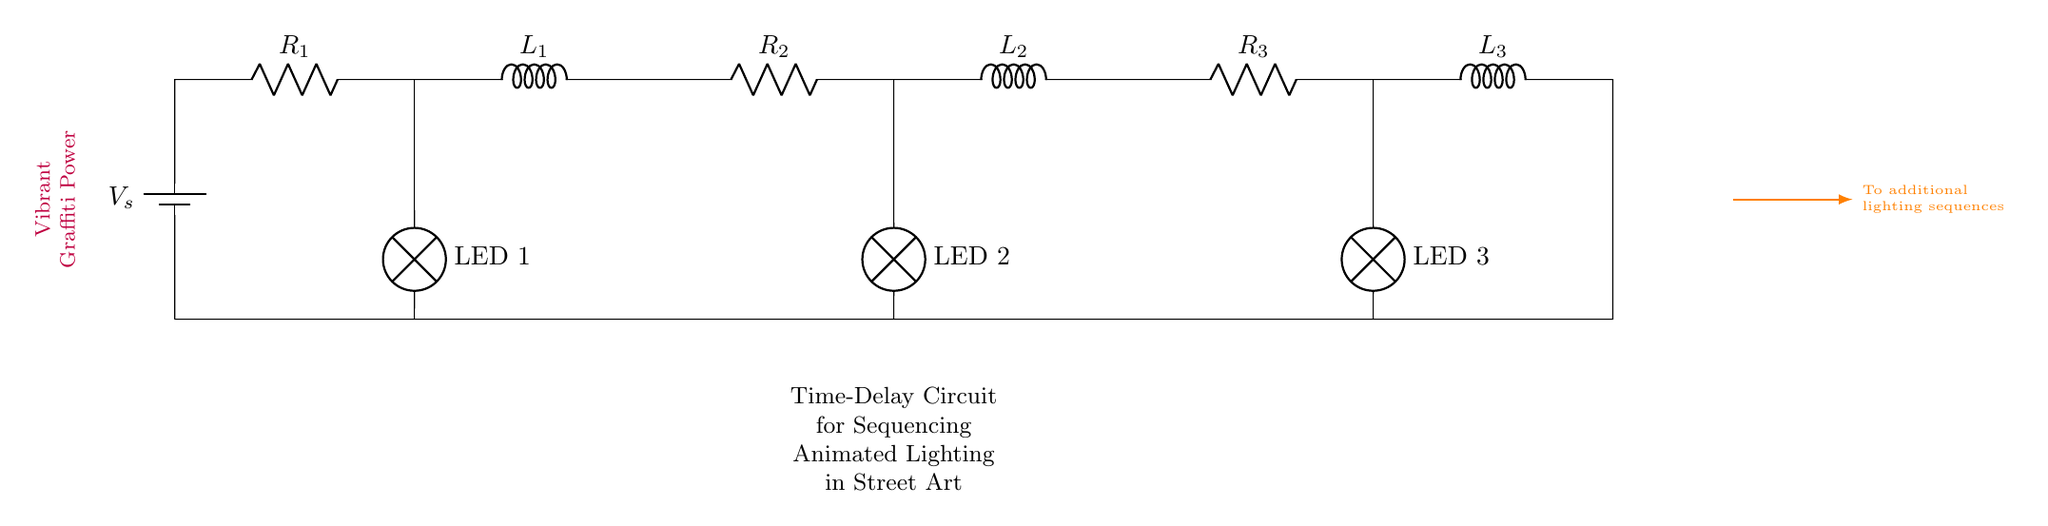What is the number of resistors in the circuit? There are three resistors shown in the circuit diagram, indicated by the symbols labeled R1, R2, and R3.
Answer: three What is the function of the inductors in this circuit? The inductors (L1, L2, and L3) are used for energy storage and to create time delays in the circuit, affecting the timing of the LED lighting sequences.
Answer: energy storage and time delays Which LED is connected to the first resistor? The first LED, labeled LED 1, is connected directly to R1, which is positioned before L1 in the circuit.
Answer: LED 1 What happens to the current when it passes through an inductor? When current passes through an inductor, it develops a magnetic field, and it resists changes in current, leading to time delays in the circuit operation.
Answer: resists changes How does the overall time delay in this circuit relate to the values of R and L? The overall time delay (τ) in an RL circuit is determined by the equation τ = L/R, where L is the inductor value and R is the resistor value. Higher values of L or lower values of R lead to longer delays.
Answer: τ = L/R What type of circuit configuration is used here? The circuit consists of a combination of series resistors and inductors arranged to create a specific timing effect for LED sequences, which indicates it is a sequential timing circuit.
Answer: sequential timing circuit 